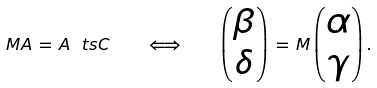Convert formula to latex. <formula><loc_0><loc_0><loc_500><loc_500>M A \, = \, A \ t s C \quad \Longleftrightarrow \quad \begin{pmatrix} \beta \\ \delta \end{pmatrix} \, = \, M \begin{pmatrix} \alpha \\ \gamma \end{pmatrix} .</formula> 